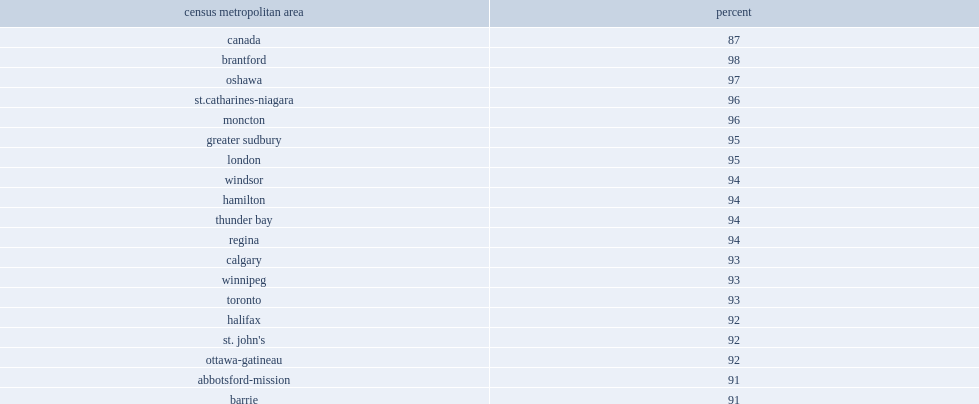Which province had the lowest levels of pride? Quebec city. What percent of residents of saguenay saying they were either proud or very proud to be canadian. 52. Outside quebec,what is the highest proportion of canadians who reported feeling proud in brantford. 98. 